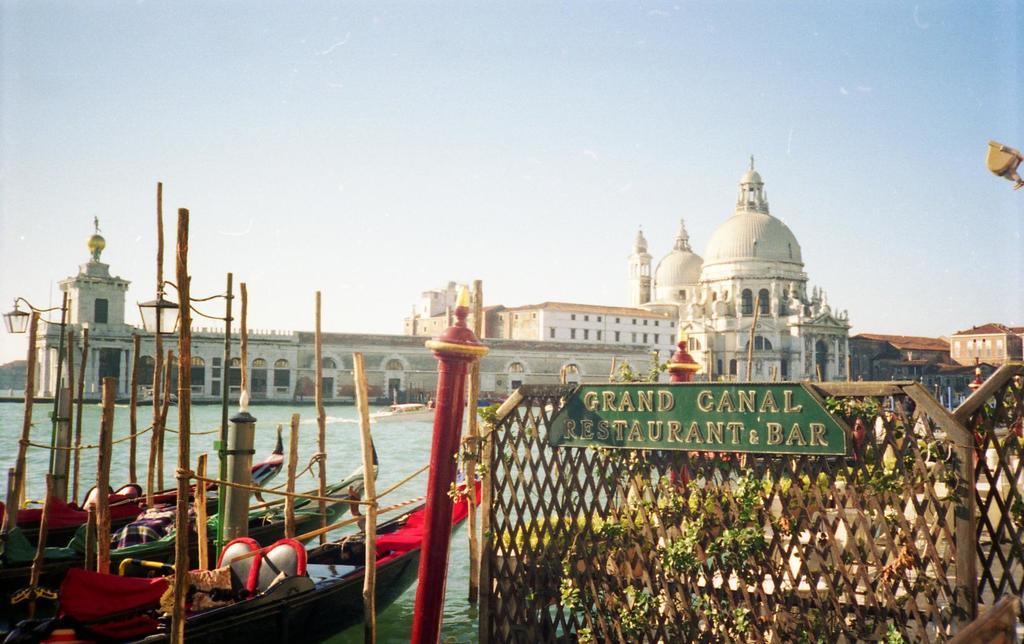What type of structures can be seen in the image? There are buildings in the image. What is the purpose of the barrier in the image? There is a fence in the image, which serves as a barrier or boundary. What is the flat, rectangular object in the image? There is a board in the image, which could be used for various purposes such as signage or display. What is the liquid visible in the image? There is water visible in the image. What is floating on the water in the image? There are boats on the water in the image. What can be seen in the background of the image? The sky is visible in the background of the image. What type of vegetation is present in the image? There are plants in the image. What note is being played by the iron in the image? There is no iron or note being played in the image. What type of love is being expressed by the plants in the image? The plants in the image are not expressing any type of love; they are simply vegetation. 